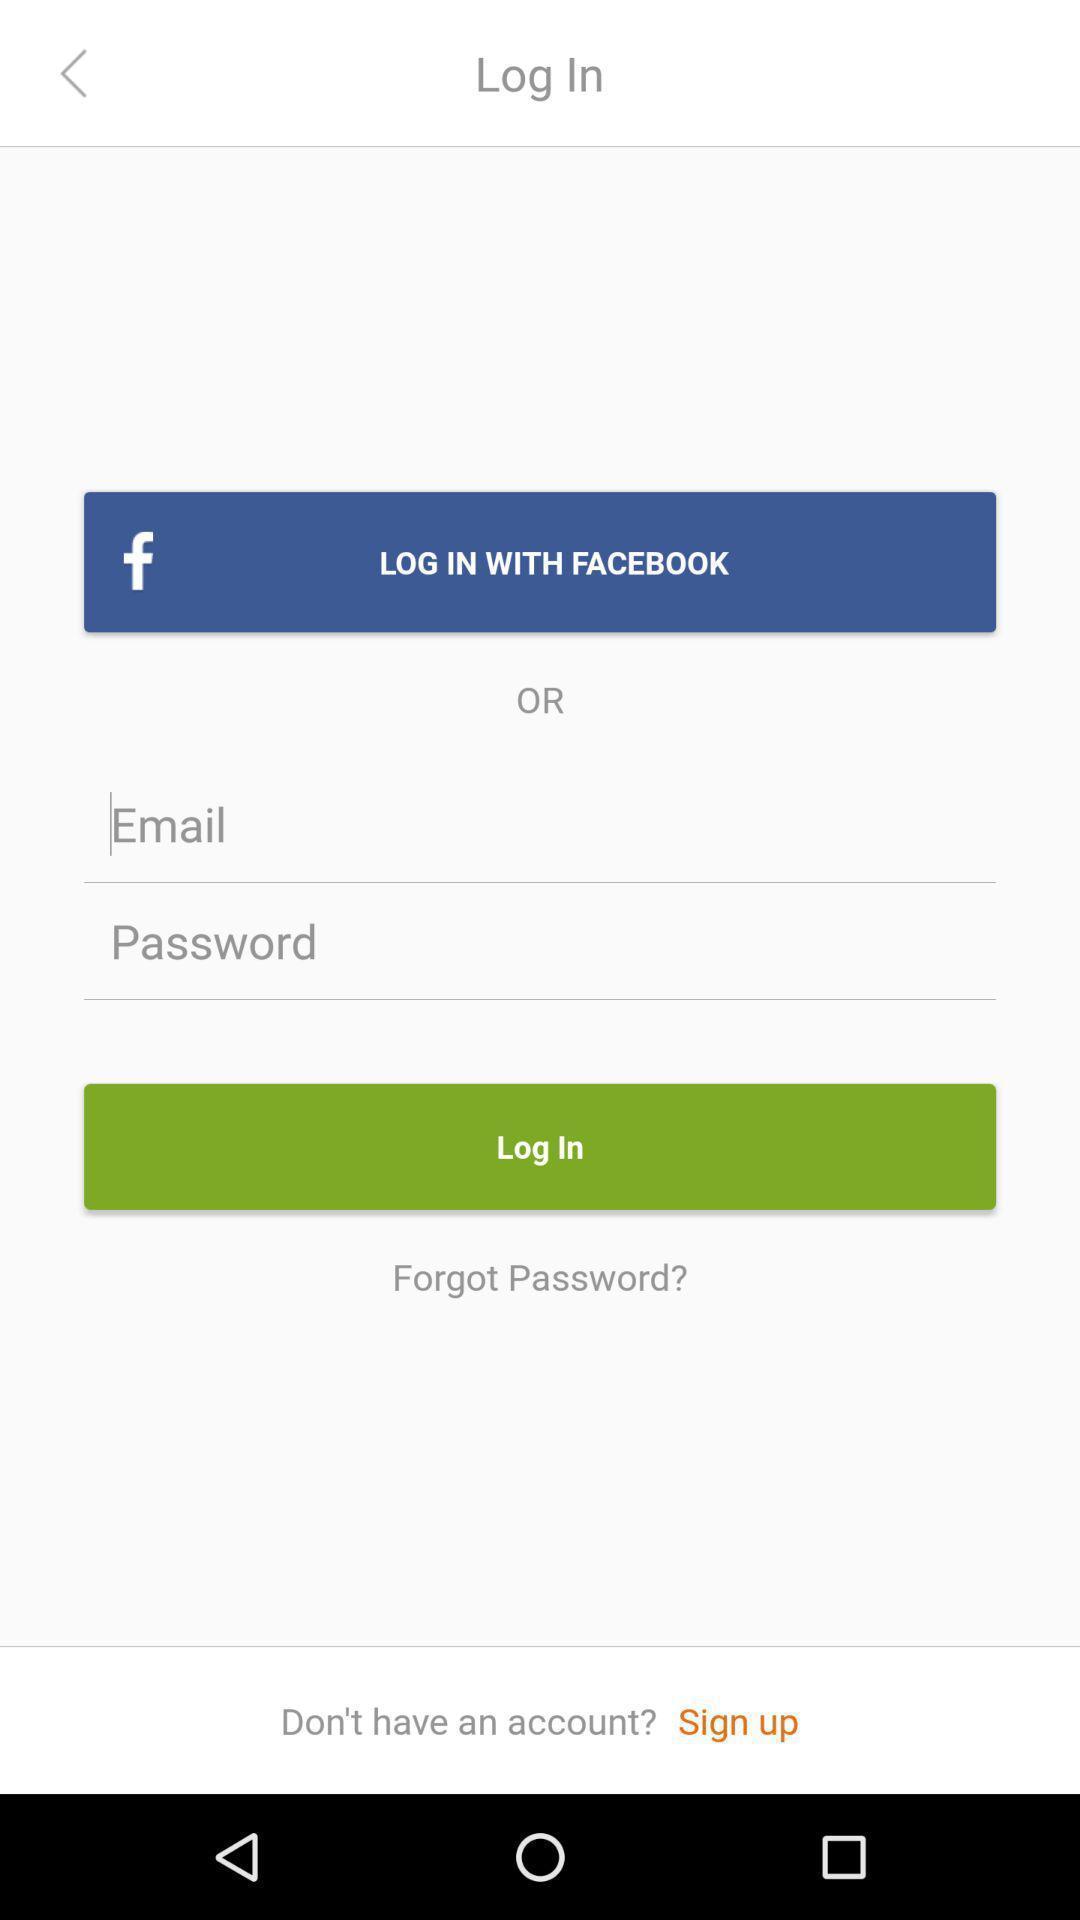Summarize the main components in this picture. Page displaying information about signing in. 